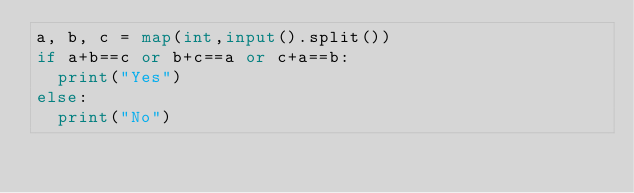Convert code to text. <code><loc_0><loc_0><loc_500><loc_500><_Python_>a, b, c = map(int,input().split())
if a+b==c or b+c==a or c+a==b:
  print("Yes")
else:
  print("No")</code> 